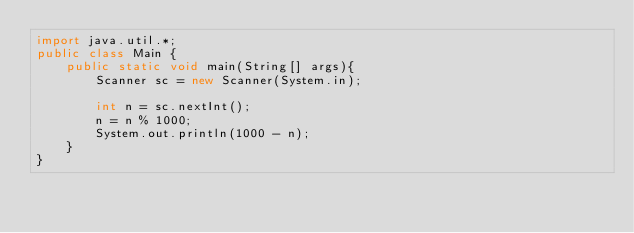<code> <loc_0><loc_0><loc_500><loc_500><_Java_>import java.util.*;
public class Main {
	public static void main(String[] args){
		Scanner sc = new Scanner(System.in);
     
		int n = sc.nextInt();
        n = n % 1000;
        System.out.println(1000 - n);
	}
}</code> 